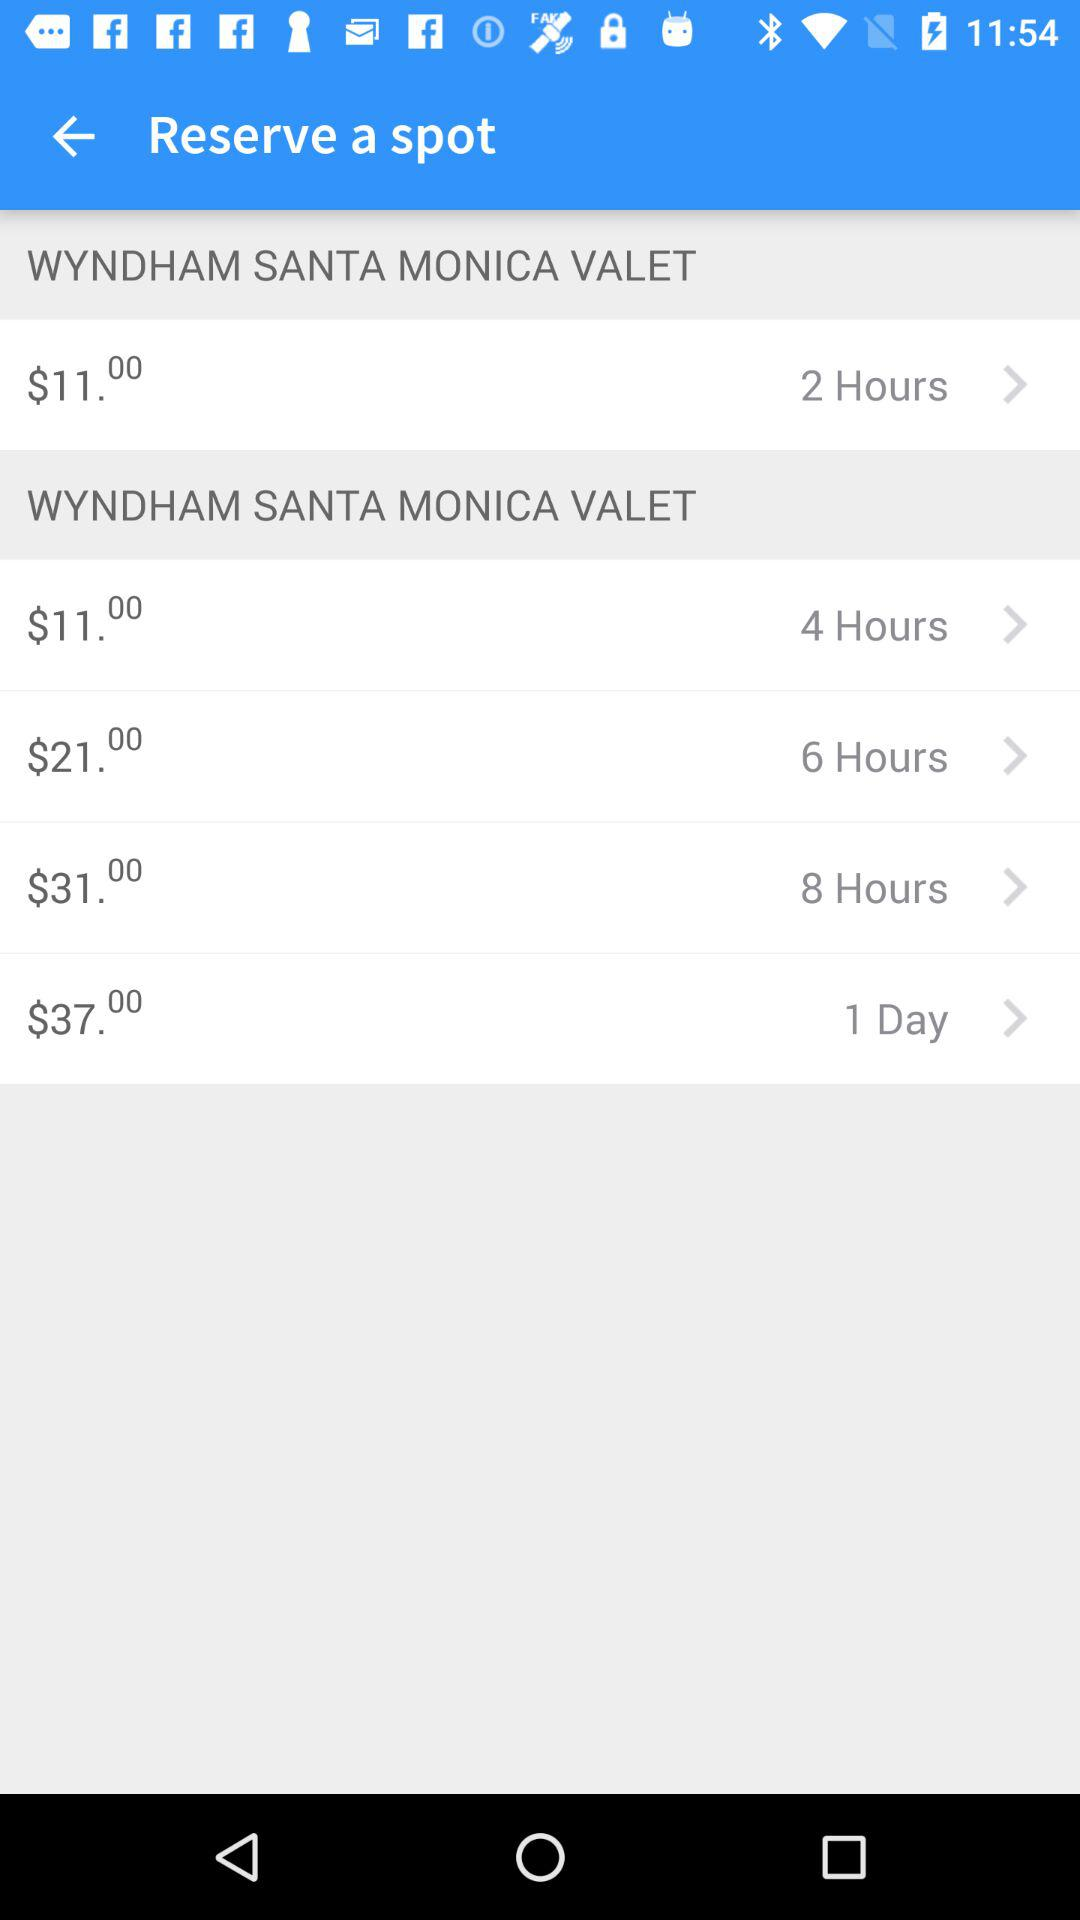How many hours can I park for $37.00?
Answer the question using a single word or phrase. 1 Day 